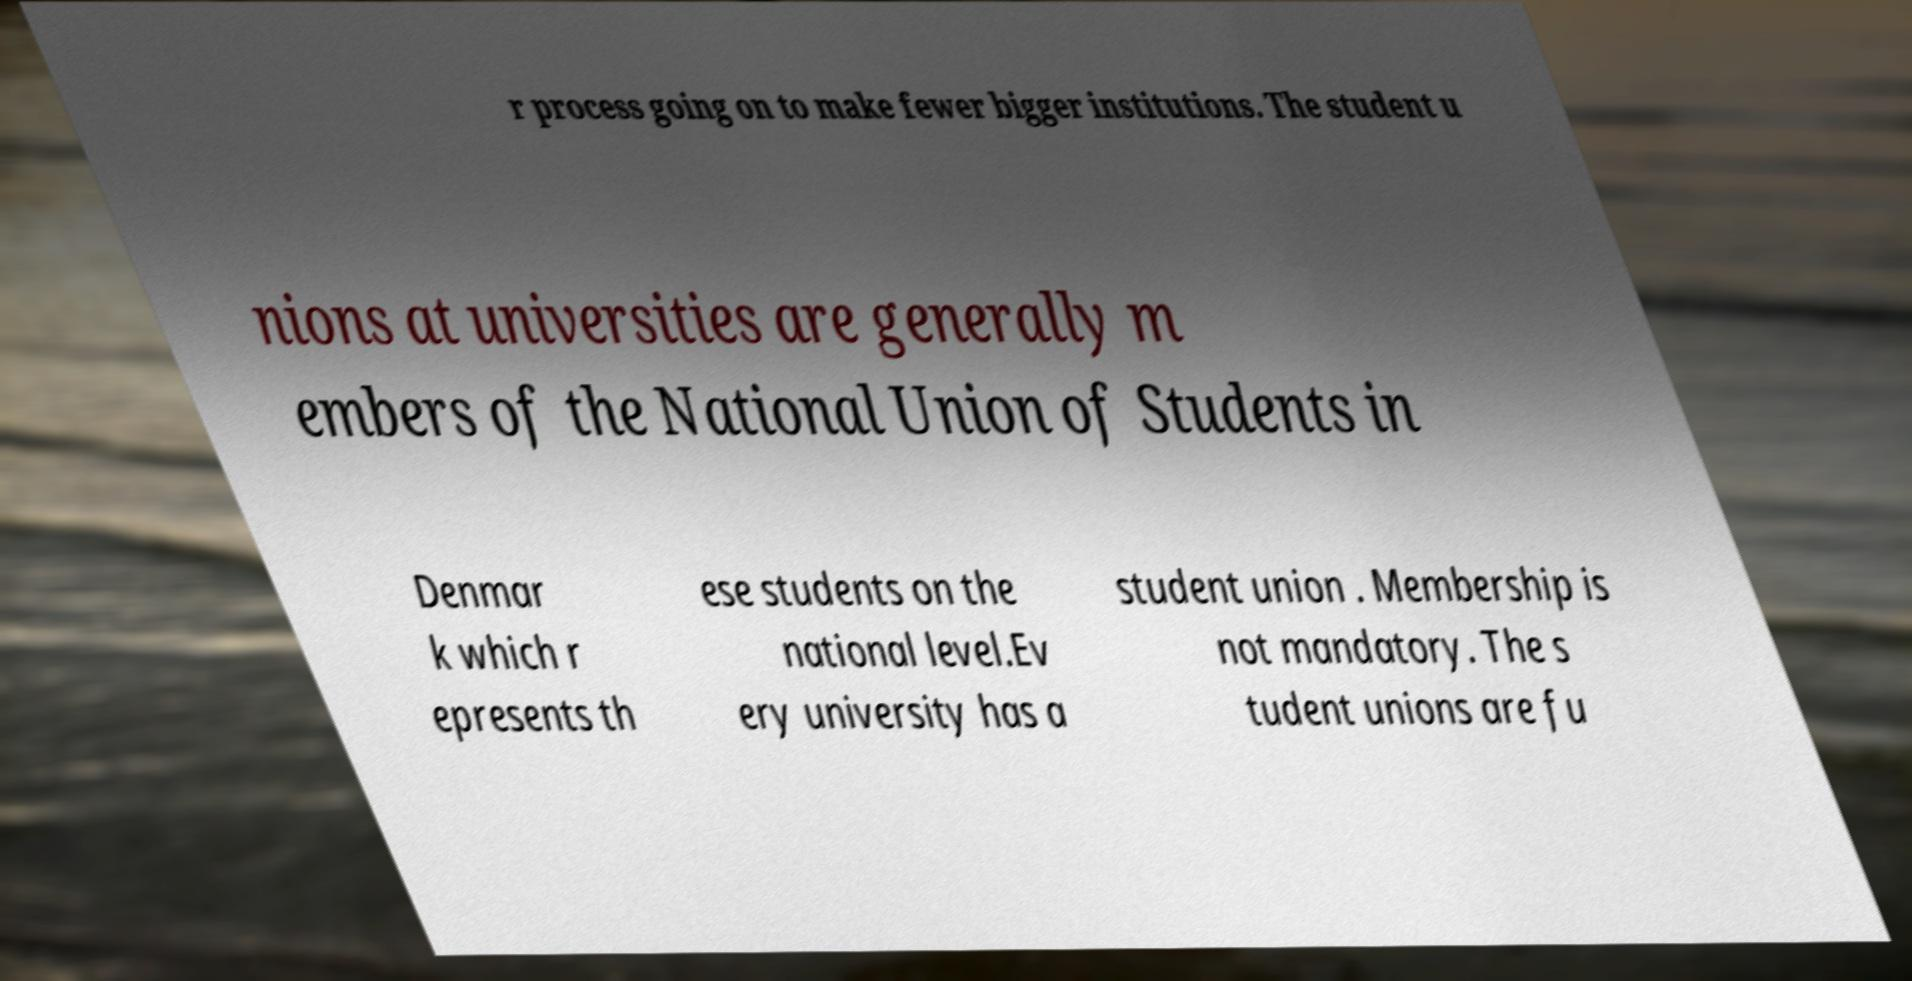For documentation purposes, I need the text within this image transcribed. Could you provide that? r process going on to make fewer bigger institutions. The student u nions at universities are generally m embers of the National Union of Students in Denmar k which r epresents th ese students on the national level.Ev ery university has a student union . Membership is not mandatory. The s tudent unions are fu 